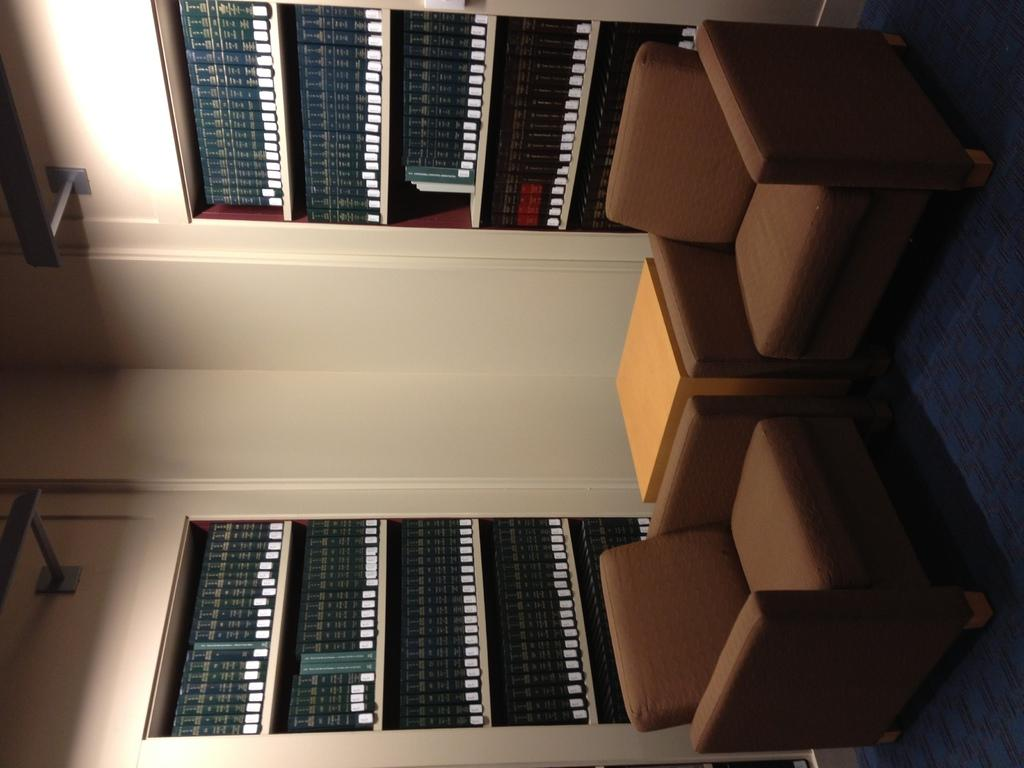What type of furniture is located on the right side of the image? There are two couches and a table on the right side of the image. What is on the wall on the left side of the image? There are bookshelves on the wall on the left side of the image. What type of nerve can be seen on the wall on the left side of the image? There are no nerves present in the image; it features couches, a table, and bookshelves on the wall. Can you tell me how many keys are on the table on the right side of the image? There is no key present on the table in the image; it only features a table and two couches. 